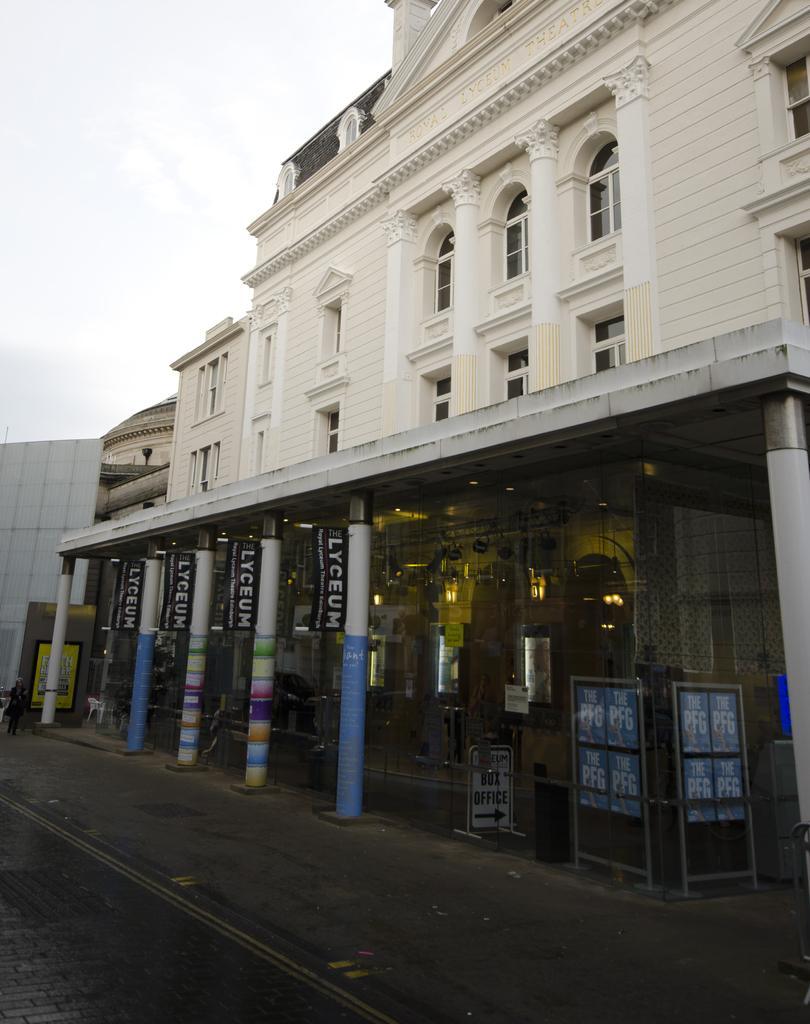Could you give a brief overview of what you see in this image? In this image, we can see buildings and on the road, we can see a signboard. 